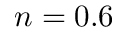Convert formula to latex. <formula><loc_0><loc_0><loc_500><loc_500>n = 0 . 6</formula> 